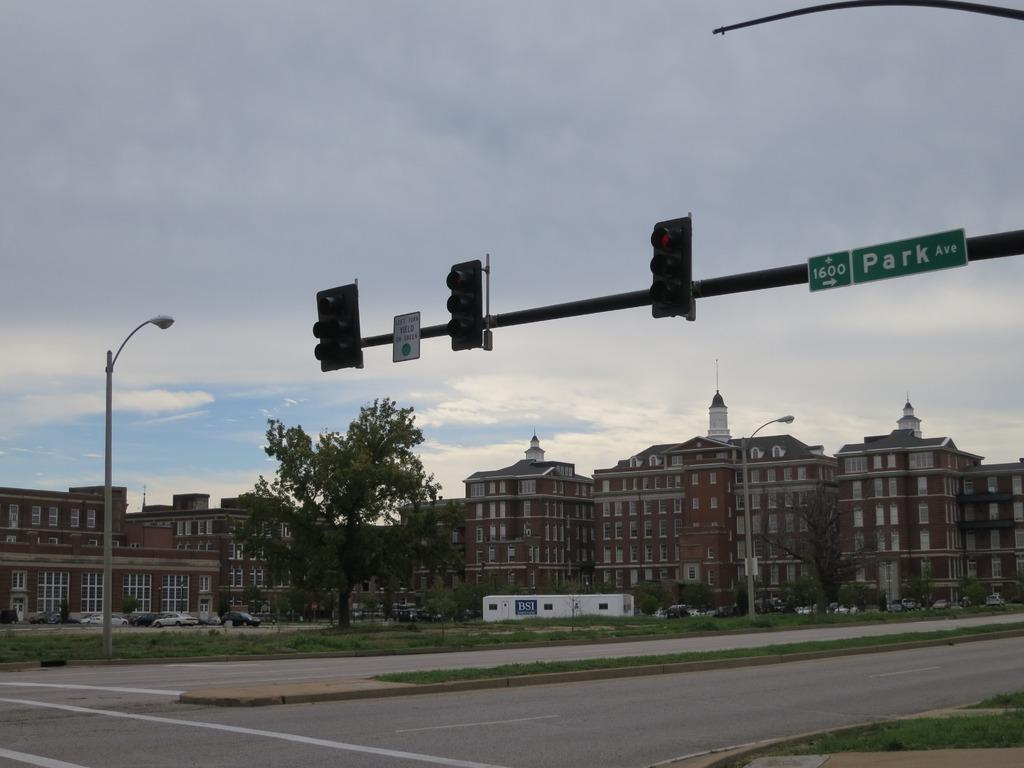<image>
Present a compact description of the photo's key features. A street junction for Park Avenue with buildings in the background. 